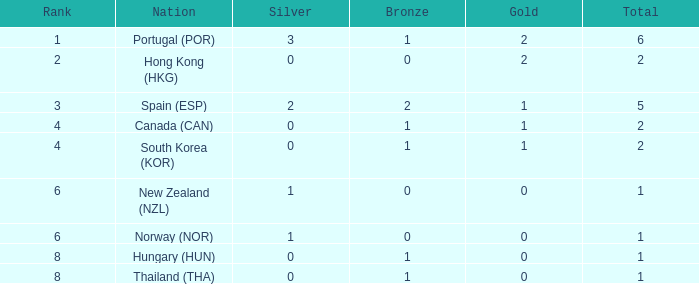Which Rank number has a Silver of 0, Gold of 2 and total smaller than 2? 0.0. 